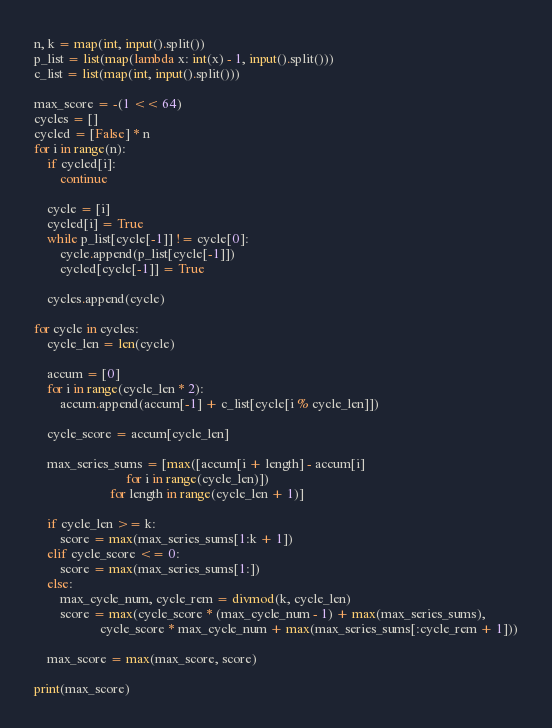<code> <loc_0><loc_0><loc_500><loc_500><_Python_>n, k = map(int, input().split())
p_list = list(map(lambda x: int(x) - 1, input().split()))
c_list = list(map(int, input().split()))

max_score = -(1 << 64)
cycles = []
cycled = [False] * n
for i in range(n):
    if cycled[i]:
        continue

    cycle = [i]
    cycled[i] = True
    while p_list[cycle[-1]] != cycle[0]:
        cycle.append(p_list[cycle[-1]])
        cycled[cycle[-1]] = True

    cycles.append(cycle)

for cycle in cycles:
    cycle_len = len(cycle)

    accum = [0]
    for i in range(cycle_len * 2):
        accum.append(accum[-1] + c_list[cycle[i % cycle_len]])

    cycle_score = accum[cycle_len]

    max_series_sums = [max([accum[i + length] - accum[i]
                            for i in range(cycle_len)])
                       for length in range(cycle_len + 1)]

    if cycle_len >= k:
        score = max(max_series_sums[1:k + 1])
    elif cycle_score <= 0:
        score = max(max_series_sums[1:])
    else:
        max_cycle_num, cycle_rem = divmod(k, cycle_len)
        score = max(cycle_score * (max_cycle_num - 1) + max(max_series_sums),
                    cycle_score * max_cycle_num + max(max_series_sums[:cycle_rem + 1]))

    max_score = max(max_score, score)

print(max_score)
</code> 